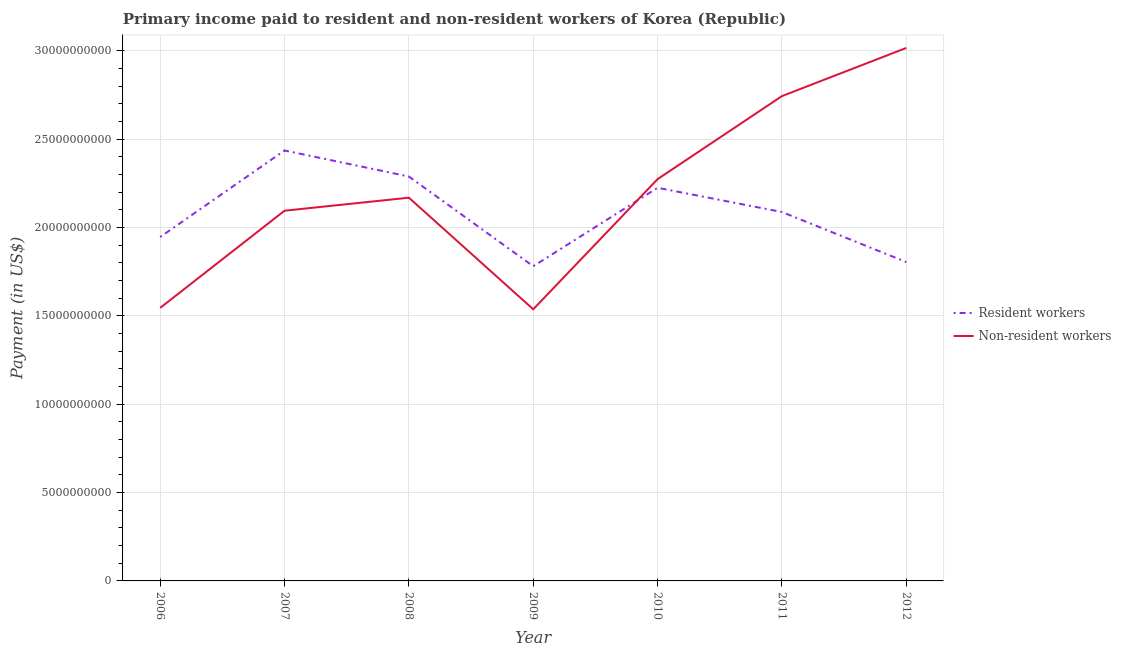Is the number of lines equal to the number of legend labels?
Offer a terse response. Yes. What is the payment made to resident workers in 2010?
Your answer should be very brief. 2.22e+1. Across all years, what is the maximum payment made to non-resident workers?
Your answer should be compact. 3.02e+1. Across all years, what is the minimum payment made to non-resident workers?
Ensure brevity in your answer.  1.54e+1. In which year was the payment made to resident workers maximum?
Give a very brief answer. 2007. In which year was the payment made to non-resident workers minimum?
Offer a terse response. 2009. What is the total payment made to resident workers in the graph?
Give a very brief answer. 1.46e+11. What is the difference between the payment made to non-resident workers in 2006 and that in 2010?
Make the answer very short. -7.29e+09. What is the difference between the payment made to non-resident workers in 2011 and the payment made to resident workers in 2009?
Provide a succinct answer. 9.63e+09. What is the average payment made to non-resident workers per year?
Give a very brief answer. 2.20e+1. In the year 2010, what is the difference between the payment made to non-resident workers and payment made to resident workers?
Provide a succinct answer. 4.90e+08. In how many years, is the payment made to resident workers greater than 15000000000 US$?
Offer a very short reply. 7. What is the ratio of the payment made to resident workers in 2008 to that in 2009?
Your response must be concise. 1.29. Is the difference between the payment made to resident workers in 2007 and 2011 greater than the difference between the payment made to non-resident workers in 2007 and 2011?
Your answer should be very brief. Yes. What is the difference between the highest and the second highest payment made to resident workers?
Your answer should be compact. 1.47e+09. What is the difference between the highest and the lowest payment made to resident workers?
Ensure brevity in your answer.  6.55e+09. Is the sum of the payment made to resident workers in 2006 and 2007 greater than the maximum payment made to non-resident workers across all years?
Provide a short and direct response. Yes. How many lines are there?
Keep it short and to the point. 2. How many years are there in the graph?
Keep it short and to the point. 7. Are the values on the major ticks of Y-axis written in scientific E-notation?
Provide a succinct answer. No. Does the graph contain any zero values?
Keep it short and to the point. No. How many legend labels are there?
Offer a very short reply. 2. What is the title of the graph?
Provide a succinct answer. Primary income paid to resident and non-resident workers of Korea (Republic). Does "2012 US$" appear as one of the legend labels in the graph?
Your response must be concise. No. What is the label or title of the X-axis?
Offer a terse response. Year. What is the label or title of the Y-axis?
Give a very brief answer. Payment (in US$). What is the Payment (in US$) of Resident workers in 2006?
Your response must be concise. 1.95e+1. What is the Payment (in US$) in Non-resident workers in 2006?
Provide a short and direct response. 1.55e+1. What is the Payment (in US$) of Resident workers in 2007?
Offer a very short reply. 2.44e+1. What is the Payment (in US$) of Non-resident workers in 2007?
Provide a succinct answer. 2.09e+1. What is the Payment (in US$) in Resident workers in 2008?
Provide a succinct answer. 2.29e+1. What is the Payment (in US$) in Non-resident workers in 2008?
Ensure brevity in your answer.  2.17e+1. What is the Payment (in US$) of Resident workers in 2009?
Make the answer very short. 1.78e+1. What is the Payment (in US$) in Non-resident workers in 2009?
Give a very brief answer. 1.54e+1. What is the Payment (in US$) in Resident workers in 2010?
Provide a short and direct response. 2.22e+1. What is the Payment (in US$) of Non-resident workers in 2010?
Give a very brief answer. 2.27e+1. What is the Payment (in US$) of Resident workers in 2011?
Ensure brevity in your answer.  2.09e+1. What is the Payment (in US$) in Non-resident workers in 2011?
Give a very brief answer. 2.74e+1. What is the Payment (in US$) of Resident workers in 2012?
Give a very brief answer. 1.80e+1. What is the Payment (in US$) of Non-resident workers in 2012?
Make the answer very short. 3.02e+1. Across all years, what is the maximum Payment (in US$) in Resident workers?
Offer a very short reply. 2.44e+1. Across all years, what is the maximum Payment (in US$) in Non-resident workers?
Make the answer very short. 3.02e+1. Across all years, what is the minimum Payment (in US$) of Resident workers?
Your answer should be compact. 1.78e+1. Across all years, what is the minimum Payment (in US$) in Non-resident workers?
Provide a short and direct response. 1.54e+1. What is the total Payment (in US$) in Resident workers in the graph?
Provide a short and direct response. 1.46e+11. What is the total Payment (in US$) of Non-resident workers in the graph?
Keep it short and to the point. 1.54e+11. What is the difference between the Payment (in US$) of Resident workers in 2006 and that in 2007?
Your answer should be very brief. -4.90e+09. What is the difference between the Payment (in US$) of Non-resident workers in 2006 and that in 2007?
Provide a succinct answer. -5.50e+09. What is the difference between the Payment (in US$) of Resident workers in 2006 and that in 2008?
Keep it short and to the point. -3.42e+09. What is the difference between the Payment (in US$) in Non-resident workers in 2006 and that in 2008?
Give a very brief answer. -6.24e+09. What is the difference between the Payment (in US$) of Resident workers in 2006 and that in 2009?
Your response must be concise. 1.65e+09. What is the difference between the Payment (in US$) in Non-resident workers in 2006 and that in 2009?
Ensure brevity in your answer.  7.94e+07. What is the difference between the Payment (in US$) in Resident workers in 2006 and that in 2010?
Give a very brief answer. -2.79e+09. What is the difference between the Payment (in US$) of Non-resident workers in 2006 and that in 2010?
Offer a very short reply. -7.29e+09. What is the difference between the Payment (in US$) in Resident workers in 2006 and that in 2011?
Ensure brevity in your answer.  -1.42e+09. What is the difference between the Payment (in US$) of Non-resident workers in 2006 and that in 2011?
Give a very brief answer. -1.20e+1. What is the difference between the Payment (in US$) of Resident workers in 2006 and that in 2012?
Keep it short and to the point. 1.42e+09. What is the difference between the Payment (in US$) in Non-resident workers in 2006 and that in 2012?
Provide a succinct answer. -1.47e+1. What is the difference between the Payment (in US$) in Resident workers in 2007 and that in 2008?
Make the answer very short. 1.47e+09. What is the difference between the Payment (in US$) of Non-resident workers in 2007 and that in 2008?
Make the answer very short. -7.37e+08. What is the difference between the Payment (in US$) in Resident workers in 2007 and that in 2009?
Keep it short and to the point. 6.55e+09. What is the difference between the Payment (in US$) of Non-resident workers in 2007 and that in 2009?
Your answer should be compact. 5.58e+09. What is the difference between the Payment (in US$) of Resident workers in 2007 and that in 2010?
Provide a short and direct response. 2.11e+09. What is the difference between the Payment (in US$) in Non-resident workers in 2007 and that in 2010?
Your response must be concise. -1.79e+09. What is the difference between the Payment (in US$) of Resident workers in 2007 and that in 2011?
Your answer should be very brief. 3.48e+09. What is the difference between the Payment (in US$) in Non-resident workers in 2007 and that in 2011?
Offer a very short reply. -6.49e+09. What is the difference between the Payment (in US$) in Resident workers in 2007 and that in 2012?
Provide a succinct answer. 6.31e+09. What is the difference between the Payment (in US$) in Non-resident workers in 2007 and that in 2012?
Offer a terse response. -9.21e+09. What is the difference between the Payment (in US$) in Resident workers in 2008 and that in 2009?
Your answer should be very brief. 5.08e+09. What is the difference between the Payment (in US$) in Non-resident workers in 2008 and that in 2009?
Your answer should be compact. 6.31e+09. What is the difference between the Payment (in US$) of Resident workers in 2008 and that in 2010?
Your response must be concise. 6.37e+08. What is the difference between the Payment (in US$) in Non-resident workers in 2008 and that in 2010?
Your answer should be compact. -1.05e+09. What is the difference between the Payment (in US$) of Resident workers in 2008 and that in 2011?
Keep it short and to the point. 2.01e+09. What is the difference between the Payment (in US$) in Non-resident workers in 2008 and that in 2011?
Ensure brevity in your answer.  -5.75e+09. What is the difference between the Payment (in US$) of Resident workers in 2008 and that in 2012?
Provide a succinct answer. 4.84e+09. What is the difference between the Payment (in US$) of Non-resident workers in 2008 and that in 2012?
Keep it short and to the point. -8.47e+09. What is the difference between the Payment (in US$) in Resident workers in 2009 and that in 2010?
Give a very brief answer. -4.44e+09. What is the difference between the Payment (in US$) in Non-resident workers in 2009 and that in 2010?
Make the answer very short. -7.37e+09. What is the difference between the Payment (in US$) of Resident workers in 2009 and that in 2011?
Your answer should be compact. -3.07e+09. What is the difference between the Payment (in US$) in Non-resident workers in 2009 and that in 2011?
Keep it short and to the point. -1.21e+1. What is the difference between the Payment (in US$) in Resident workers in 2009 and that in 2012?
Offer a very short reply. -2.36e+08. What is the difference between the Payment (in US$) in Non-resident workers in 2009 and that in 2012?
Your response must be concise. -1.48e+1. What is the difference between the Payment (in US$) in Resident workers in 2010 and that in 2011?
Offer a terse response. 1.37e+09. What is the difference between the Payment (in US$) of Non-resident workers in 2010 and that in 2011?
Provide a succinct answer. -4.70e+09. What is the difference between the Payment (in US$) of Resident workers in 2010 and that in 2012?
Give a very brief answer. 4.20e+09. What is the difference between the Payment (in US$) in Non-resident workers in 2010 and that in 2012?
Your answer should be compact. -7.42e+09. What is the difference between the Payment (in US$) in Resident workers in 2011 and that in 2012?
Offer a very short reply. 2.83e+09. What is the difference between the Payment (in US$) of Non-resident workers in 2011 and that in 2012?
Your response must be concise. -2.72e+09. What is the difference between the Payment (in US$) in Resident workers in 2006 and the Payment (in US$) in Non-resident workers in 2007?
Ensure brevity in your answer.  -1.49e+09. What is the difference between the Payment (in US$) in Resident workers in 2006 and the Payment (in US$) in Non-resident workers in 2008?
Keep it short and to the point. -2.23e+09. What is the difference between the Payment (in US$) of Resident workers in 2006 and the Payment (in US$) of Non-resident workers in 2009?
Provide a succinct answer. 4.09e+09. What is the difference between the Payment (in US$) in Resident workers in 2006 and the Payment (in US$) in Non-resident workers in 2010?
Offer a very short reply. -3.28e+09. What is the difference between the Payment (in US$) in Resident workers in 2006 and the Payment (in US$) in Non-resident workers in 2011?
Offer a very short reply. -7.98e+09. What is the difference between the Payment (in US$) in Resident workers in 2006 and the Payment (in US$) in Non-resident workers in 2012?
Ensure brevity in your answer.  -1.07e+1. What is the difference between the Payment (in US$) of Resident workers in 2007 and the Payment (in US$) of Non-resident workers in 2008?
Offer a terse response. 2.67e+09. What is the difference between the Payment (in US$) of Resident workers in 2007 and the Payment (in US$) of Non-resident workers in 2009?
Provide a short and direct response. 8.99e+09. What is the difference between the Payment (in US$) of Resident workers in 2007 and the Payment (in US$) of Non-resident workers in 2010?
Provide a succinct answer. 1.62e+09. What is the difference between the Payment (in US$) in Resident workers in 2007 and the Payment (in US$) in Non-resident workers in 2011?
Your answer should be very brief. -3.08e+09. What is the difference between the Payment (in US$) in Resident workers in 2007 and the Payment (in US$) in Non-resident workers in 2012?
Make the answer very short. -5.80e+09. What is the difference between the Payment (in US$) in Resident workers in 2008 and the Payment (in US$) in Non-resident workers in 2009?
Provide a short and direct response. 7.51e+09. What is the difference between the Payment (in US$) in Resident workers in 2008 and the Payment (in US$) in Non-resident workers in 2010?
Offer a very short reply. 1.47e+08. What is the difference between the Payment (in US$) in Resident workers in 2008 and the Payment (in US$) in Non-resident workers in 2011?
Give a very brief answer. -4.55e+09. What is the difference between the Payment (in US$) in Resident workers in 2008 and the Payment (in US$) in Non-resident workers in 2012?
Make the answer very short. -7.28e+09. What is the difference between the Payment (in US$) in Resident workers in 2009 and the Payment (in US$) in Non-resident workers in 2010?
Offer a very short reply. -4.93e+09. What is the difference between the Payment (in US$) in Resident workers in 2009 and the Payment (in US$) in Non-resident workers in 2011?
Your response must be concise. -9.63e+09. What is the difference between the Payment (in US$) in Resident workers in 2009 and the Payment (in US$) in Non-resident workers in 2012?
Your answer should be very brief. -1.24e+1. What is the difference between the Payment (in US$) of Resident workers in 2010 and the Payment (in US$) of Non-resident workers in 2011?
Your answer should be very brief. -5.19e+09. What is the difference between the Payment (in US$) in Resident workers in 2010 and the Payment (in US$) in Non-resident workers in 2012?
Give a very brief answer. -7.91e+09. What is the difference between the Payment (in US$) of Resident workers in 2011 and the Payment (in US$) of Non-resident workers in 2012?
Your answer should be very brief. -9.28e+09. What is the average Payment (in US$) in Resident workers per year?
Give a very brief answer. 2.08e+1. What is the average Payment (in US$) of Non-resident workers per year?
Your answer should be compact. 2.20e+1. In the year 2006, what is the difference between the Payment (in US$) in Resident workers and Payment (in US$) in Non-resident workers?
Your answer should be compact. 4.01e+09. In the year 2007, what is the difference between the Payment (in US$) of Resident workers and Payment (in US$) of Non-resident workers?
Provide a succinct answer. 3.41e+09. In the year 2008, what is the difference between the Payment (in US$) in Resident workers and Payment (in US$) in Non-resident workers?
Keep it short and to the point. 1.20e+09. In the year 2009, what is the difference between the Payment (in US$) in Resident workers and Payment (in US$) in Non-resident workers?
Your answer should be very brief. 2.44e+09. In the year 2010, what is the difference between the Payment (in US$) in Resident workers and Payment (in US$) in Non-resident workers?
Your answer should be compact. -4.90e+08. In the year 2011, what is the difference between the Payment (in US$) of Resident workers and Payment (in US$) of Non-resident workers?
Your answer should be very brief. -6.56e+09. In the year 2012, what is the difference between the Payment (in US$) of Resident workers and Payment (in US$) of Non-resident workers?
Give a very brief answer. -1.21e+1. What is the ratio of the Payment (in US$) in Resident workers in 2006 to that in 2007?
Your answer should be very brief. 0.8. What is the ratio of the Payment (in US$) in Non-resident workers in 2006 to that in 2007?
Offer a very short reply. 0.74. What is the ratio of the Payment (in US$) in Resident workers in 2006 to that in 2008?
Make the answer very short. 0.85. What is the ratio of the Payment (in US$) in Non-resident workers in 2006 to that in 2008?
Your response must be concise. 0.71. What is the ratio of the Payment (in US$) in Resident workers in 2006 to that in 2009?
Your answer should be compact. 1.09. What is the ratio of the Payment (in US$) in Resident workers in 2006 to that in 2010?
Your response must be concise. 0.87. What is the ratio of the Payment (in US$) of Non-resident workers in 2006 to that in 2010?
Your answer should be compact. 0.68. What is the ratio of the Payment (in US$) of Resident workers in 2006 to that in 2011?
Make the answer very short. 0.93. What is the ratio of the Payment (in US$) in Non-resident workers in 2006 to that in 2011?
Give a very brief answer. 0.56. What is the ratio of the Payment (in US$) of Resident workers in 2006 to that in 2012?
Offer a terse response. 1.08. What is the ratio of the Payment (in US$) in Non-resident workers in 2006 to that in 2012?
Give a very brief answer. 0.51. What is the ratio of the Payment (in US$) of Resident workers in 2007 to that in 2008?
Your answer should be very brief. 1.06. What is the ratio of the Payment (in US$) of Non-resident workers in 2007 to that in 2008?
Keep it short and to the point. 0.97. What is the ratio of the Payment (in US$) in Resident workers in 2007 to that in 2009?
Offer a terse response. 1.37. What is the ratio of the Payment (in US$) of Non-resident workers in 2007 to that in 2009?
Offer a terse response. 1.36. What is the ratio of the Payment (in US$) of Resident workers in 2007 to that in 2010?
Provide a short and direct response. 1.09. What is the ratio of the Payment (in US$) of Non-resident workers in 2007 to that in 2010?
Offer a terse response. 0.92. What is the ratio of the Payment (in US$) in Resident workers in 2007 to that in 2011?
Your answer should be compact. 1.17. What is the ratio of the Payment (in US$) in Non-resident workers in 2007 to that in 2011?
Provide a short and direct response. 0.76. What is the ratio of the Payment (in US$) of Resident workers in 2007 to that in 2012?
Provide a succinct answer. 1.35. What is the ratio of the Payment (in US$) in Non-resident workers in 2007 to that in 2012?
Make the answer very short. 0.69. What is the ratio of the Payment (in US$) in Resident workers in 2008 to that in 2009?
Offer a terse response. 1.29. What is the ratio of the Payment (in US$) of Non-resident workers in 2008 to that in 2009?
Ensure brevity in your answer.  1.41. What is the ratio of the Payment (in US$) of Resident workers in 2008 to that in 2010?
Your answer should be very brief. 1.03. What is the ratio of the Payment (in US$) in Non-resident workers in 2008 to that in 2010?
Make the answer very short. 0.95. What is the ratio of the Payment (in US$) of Resident workers in 2008 to that in 2011?
Give a very brief answer. 1.1. What is the ratio of the Payment (in US$) of Non-resident workers in 2008 to that in 2011?
Give a very brief answer. 0.79. What is the ratio of the Payment (in US$) in Resident workers in 2008 to that in 2012?
Provide a succinct answer. 1.27. What is the ratio of the Payment (in US$) of Non-resident workers in 2008 to that in 2012?
Your answer should be compact. 0.72. What is the ratio of the Payment (in US$) of Resident workers in 2009 to that in 2010?
Give a very brief answer. 0.8. What is the ratio of the Payment (in US$) in Non-resident workers in 2009 to that in 2010?
Provide a succinct answer. 0.68. What is the ratio of the Payment (in US$) of Resident workers in 2009 to that in 2011?
Your answer should be compact. 0.85. What is the ratio of the Payment (in US$) in Non-resident workers in 2009 to that in 2011?
Your answer should be very brief. 0.56. What is the ratio of the Payment (in US$) of Resident workers in 2009 to that in 2012?
Make the answer very short. 0.99. What is the ratio of the Payment (in US$) of Non-resident workers in 2009 to that in 2012?
Your answer should be very brief. 0.51. What is the ratio of the Payment (in US$) of Resident workers in 2010 to that in 2011?
Keep it short and to the point. 1.07. What is the ratio of the Payment (in US$) of Non-resident workers in 2010 to that in 2011?
Provide a short and direct response. 0.83. What is the ratio of the Payment (in US$) of Resident workers in 2010 to that in 2012?
Your answer should be very brief. 1.23. What is the ratio of the Payment (in US$) of Non-resident workers in 2010 to that in 2012?
Offer a terse response. 0.75. What is the ratio of the Payment (in US$) of Resident workers in 2011 to that in 2012?
Give a very brief answer. 1.16. What is the ratio of the Payment (in US$) in Non-resident workers in 2011 to that in 2012?
Give a very brief answer. 0.91. What is the difference between the highest and the second highest Payment (in US$) of Resident workers?
Provide a short and direct response. 1.47e+09. What is the difference between the highest and the second highest Payment (in US$) in Non-resident workers?
Give a very brief answer. 2.72e+09. What is the difference between the highest and the lowest Payment (in US$) in Resident workers?
Your response must be concise. 6.55e+09. What is the difference between the highest and the lowest Payment (in US$) in Non-resident workers?
Your response must be concise. 1.48e+1. 